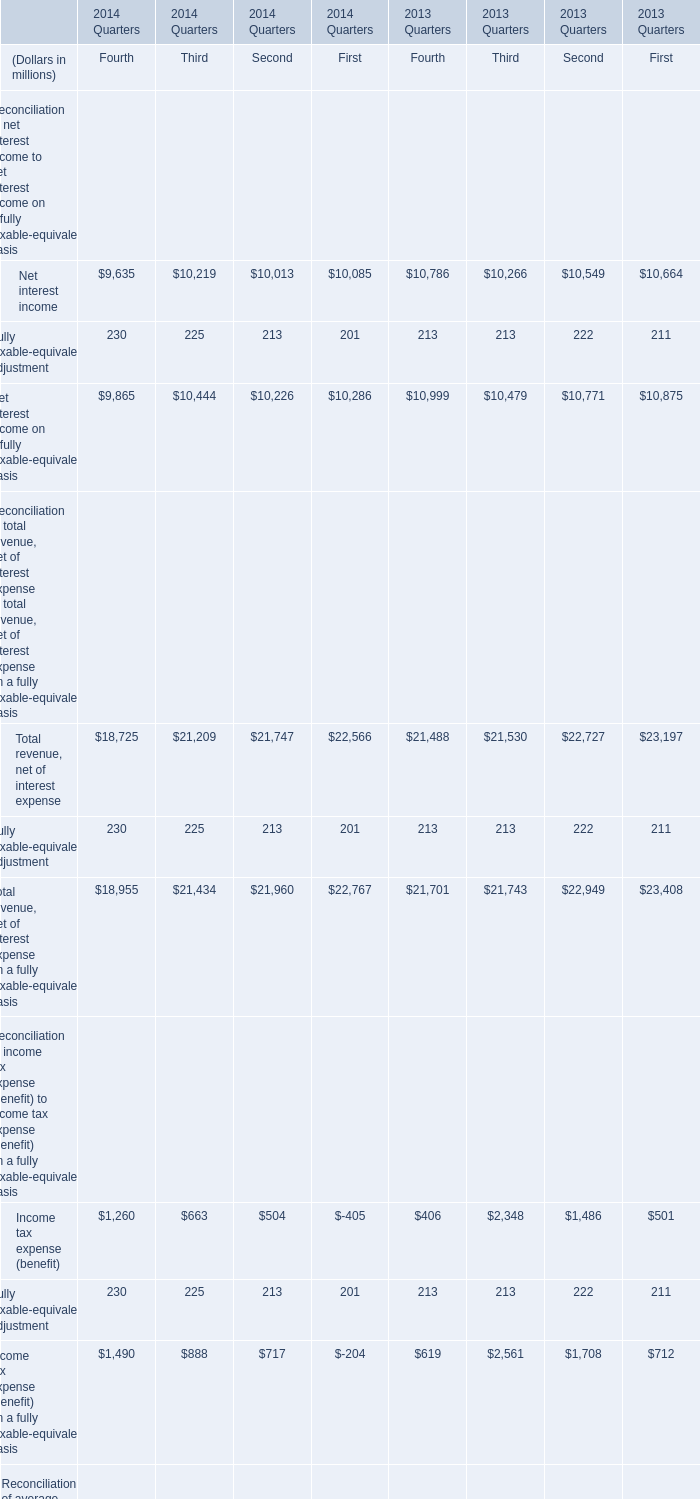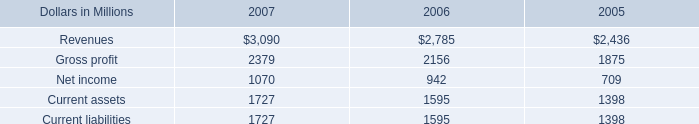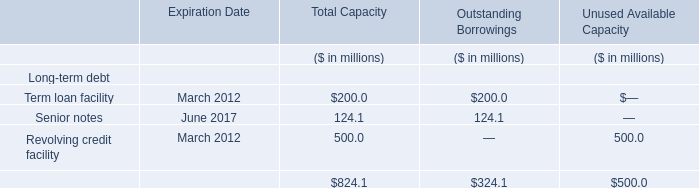Which year is Tangible assets of the Fourth Quarter in terms of Reconciliation of period-end assets to period-end tangible assets of the Fourth Quarter the highest? 
Answer: 2014. 